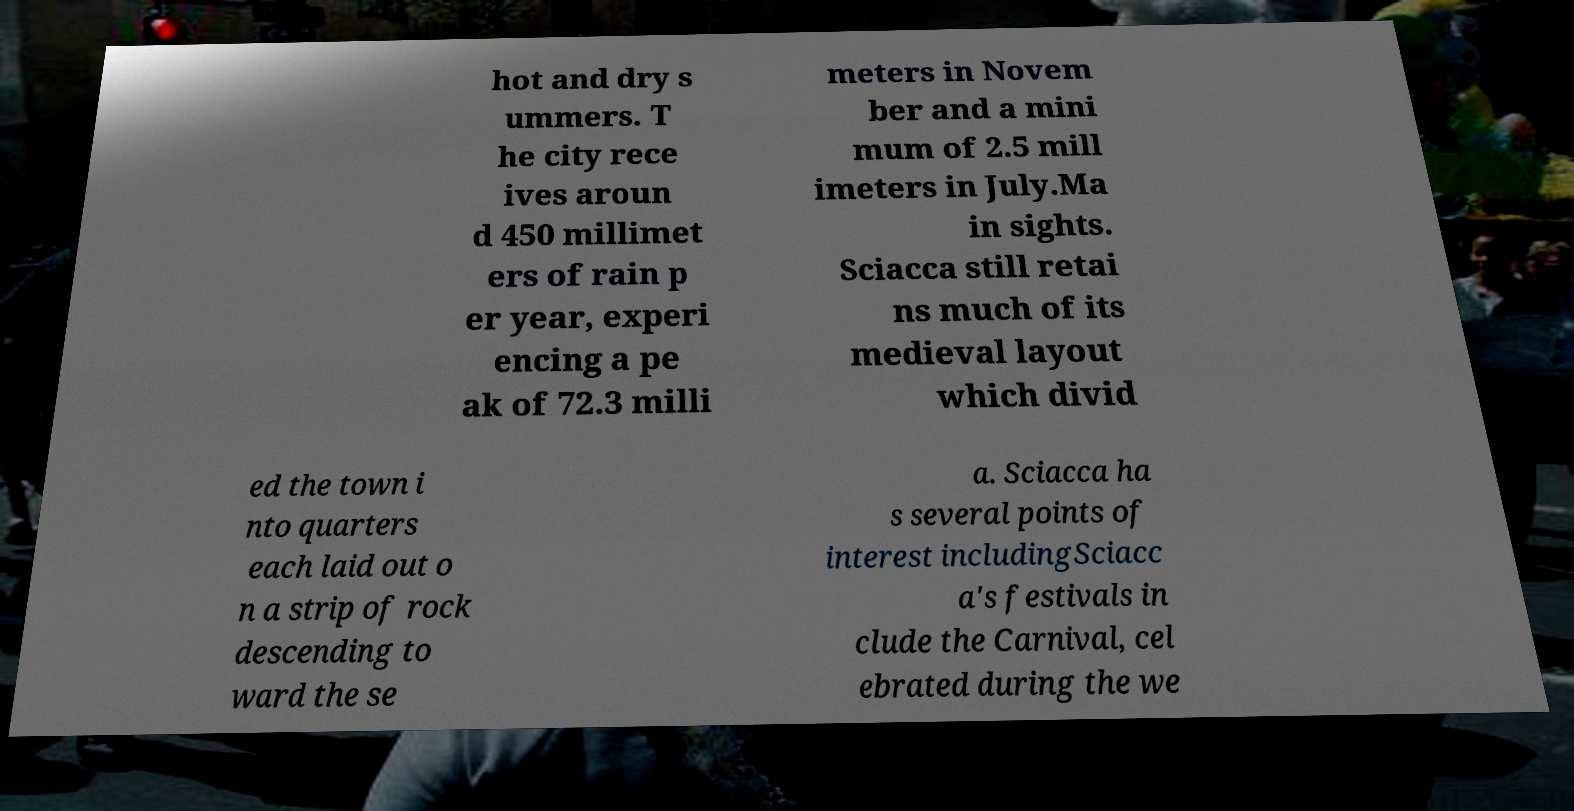Please read and relay the text visible in this image. What does it say? hot and dry s ummers. T he city rece ives aroun d 450 millimet ers of rain p er year, experi encing a pe ak of 72.3 milli meters in Novem ber and a mini mum of 2.5 mill imeters in July.Ma in sights. Sciacca still retai ns much of its medieval layout which divid ed the town i nto quarters each laid out o n a strip of rock descending to ward the se a. Sciacca ha s several points of interest includingSciacc a's festivals in clude the Carnival, cel ebrated during the we 